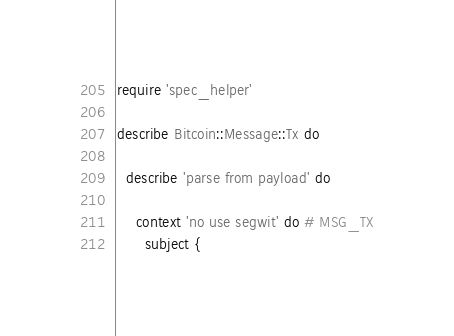<code> <loc_0><loc_0><loc_500><loc_500><_Ruby_>require 'spec_helper'

describe Bitcoin::Message::Tx do

  describe 'parse from payload' do

    context 'no use segwit' do # MSG_TX
      subject {</code> 